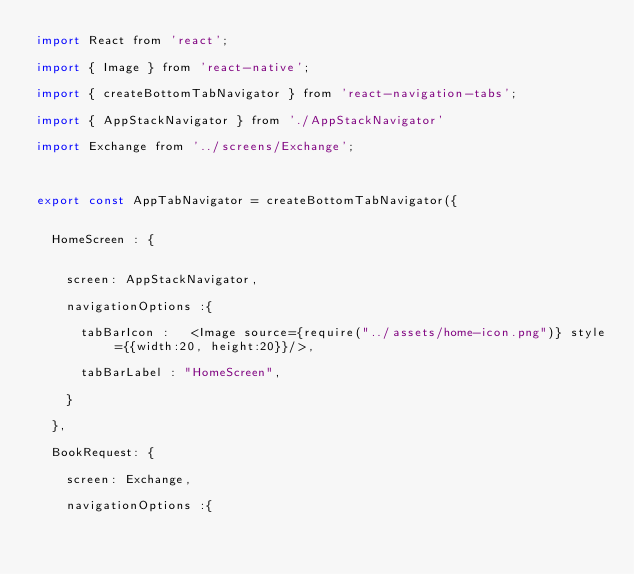Convert code to text. <code><loc_0><loc_0><loc_500><loc_500><_JavaScript_>import React from 'react';

import { Image } from 'react-native';

import { createBottomTabNavigator } from 'react-navigation-tabs';

import { AppStackNavigator } from './AppStackNavigator'

import Exchange from '../screens/Exchange';



export const AppTabNavigator = createBottomTabNavigator({


  HomeScreen : {


    screen: AppStackNavigator,

    navigationOptions :{

      tabBarIcon :   <Image source={require("../assets/home-icon.png")} style={{width:20, height:20}}/>,

      tabBarLabel : "HomeScreen",

    }

  },

  BookRequest: {

    screen: Exchange,

    navigationOptions :{
</code> 